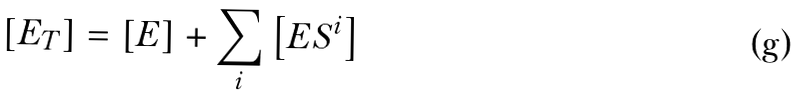<formula> <loc_0><loc_0><loc_500><loc_500>\left [ E _ { T } \right ] = \left [ E \right ] + \sum _ { i } \left [ E S ^ { i } \right ]</formula> 